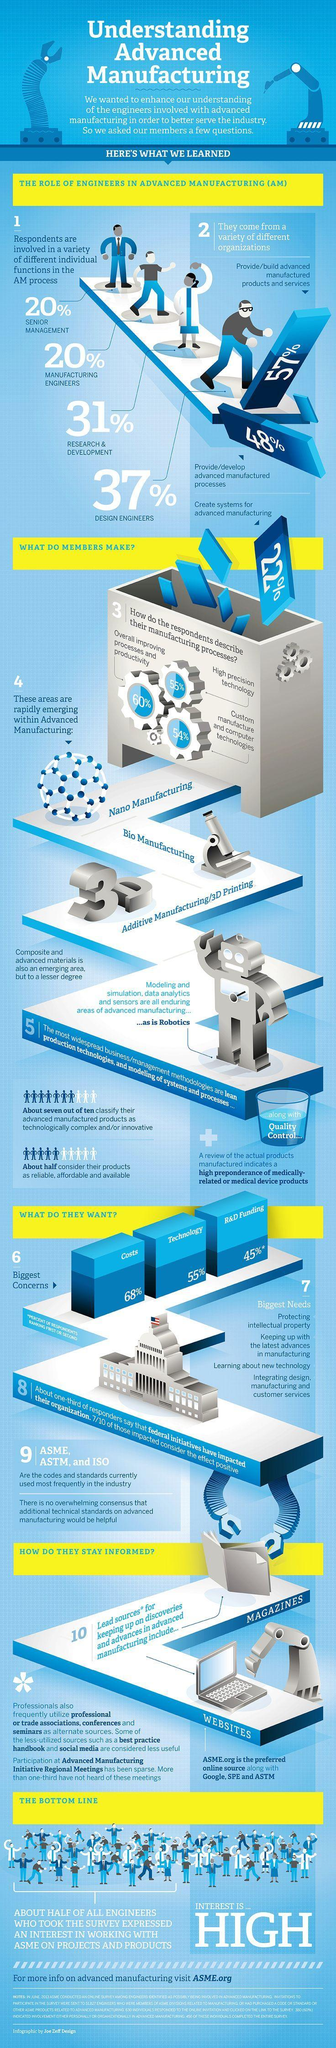What is the percentage of respondents that describe their manufacturing process as High precision technology 60%, 54%, or 55%?
Answer the question with a short phrase. 55% How many codes or standards are the most frequently used in the industry? 3 Calculate the total percentage of engineers involved in the advanced manufacturing process? 108% What is the total percentage of the Technology and R&D funding ? 100% How many types manufacturing processes are listed? 3 